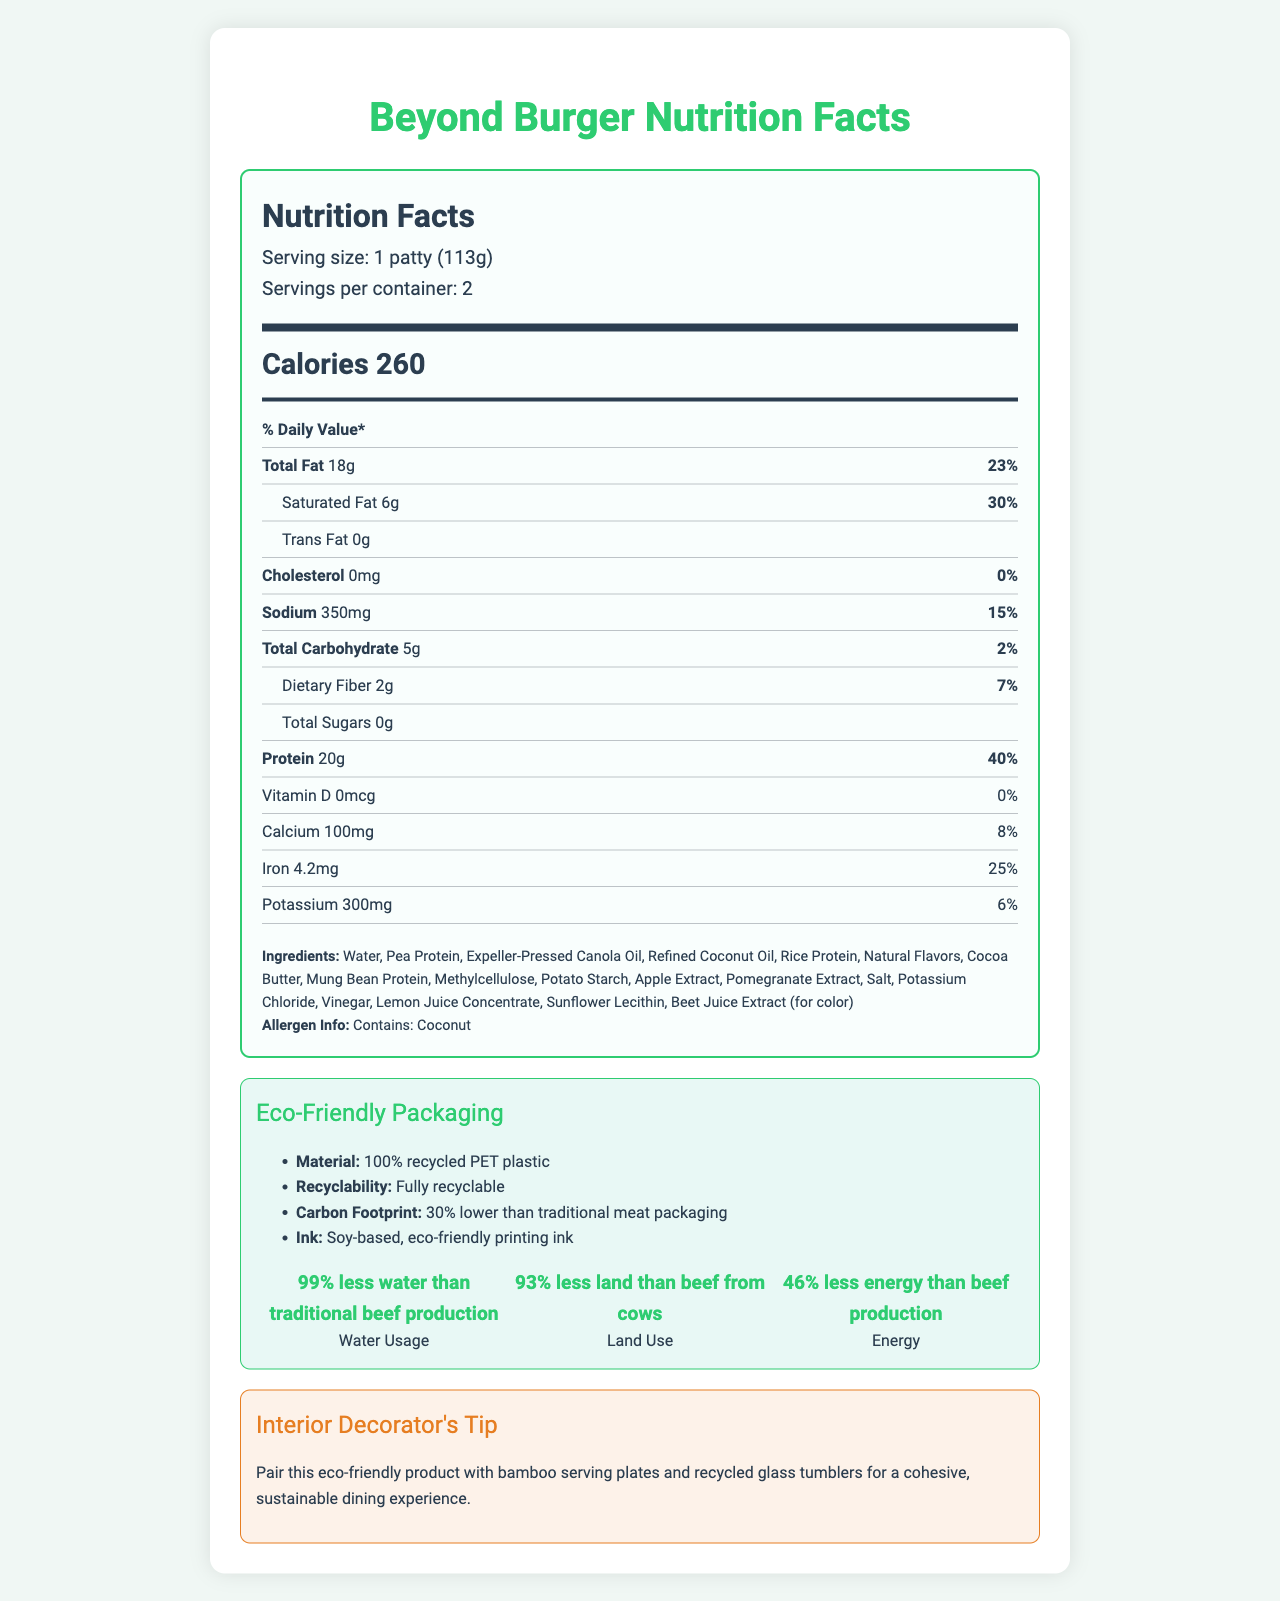What is the serving size of Beyond Burger? The document states that the serving size is 1 patty (113g).
Answer: 1 patty (113g) How many calories are in one serving of Beyond Burger? The document indicates that there are 260 calories in one serving.
Answer: 260 What percentage of the daily value of saturated fat does one serving provide? The document lists that one serving contains 6g of saturated fat which is 30% of the daily value.
Answer: 30% What is the total carbohydrate content per serving? The document specifies that there are 5g of total carbohydrates in one serving.
Answer: 5g List two ingredients found in Beyond Burger. The ingredients listed in the document include Pea Protein and Coconut Oil among others.
Answer: Pea Protein, Coconut Oil Which of the following allergens are present in Beyond Burger? A. Peanut B. Soy C. Coconut D. Dairy The allergen information states that the product contains Coconut.
Answer: C What are the environmental benefits of choosing Beyond Burger compared to traditional beef? A. Less water usage B. Less land use C. Less energy consumption D. All of the above The sustainability notes indicate that Beyond Burger uses 99% less water, 93% less land, and 46% less energy compared to traditional beef production.
Answer: D Is the packaging of Beyond Burger recyclable? The eco-friendly packaging section states that the packaging is fully recyclable.
Answer: Yes Does Beyond Burger contain any cholesterol? The document specifies that Beyond Burger contains 0mg cholesterol, which is 0% of the daily value.
Answer: No Briefly summarize the eco-friendly features of Beyond Burger. The eco-friendly packaging section details these specific features.
Answer: Beyond Burger utilizes 100% recycled PET plastic for packaging, which is fully recyclable and has a 30% lower carbon footprint than traditional meat packaging. It also uses soy-based, eco-friendly printing ink. What is the daily value percentage of protein provided by one serving of Beyond Burger? The document specifies that one serving has 20g of protein, which corresponds to 40% of the daily value.
Answer: 40% Are there any sugars in Beyond Burger? The document indicates that there are 0g of total sugars in Beyond Burger.
Answer: No How much calcium does one serving of Beyond Burger contain? The document states that one serving contains 100mg of calcium, which is 8% of the daily value.
Answer: 100mg What is the main idea of the document? The document comprehensively details the nutritional facts including calorie and nutrient content, ingredients, and highlights eco-friendly features of the Beyond Burger.
Answer: The document provides nutritional information, ingredients, allergen details, eco-friendly packaging details, and sustainability benefits of the Beyond Burger, along with a decorating tip that matches its eco-friendly nature. What is the recycling symbol on the Beyond Burger package? The document mentions that the packaging is fully recyclable but does not provide an image or description of the recycling symbol.
Answer: I don't know What material is used for the packaging of Beyond Burger? The eco-friendly packaging section specifies that the packaging is made from 100% recycled PET plastic.
Answer: 100% recycled PET plastic 